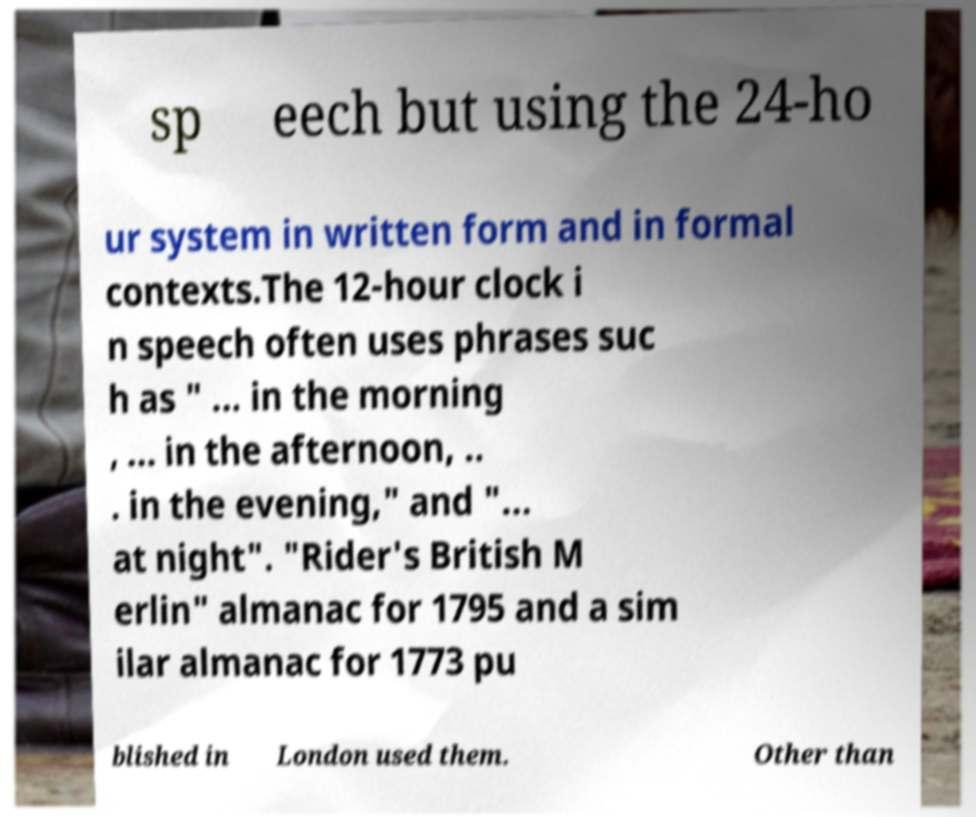Can you read and provide the text displayed in the image?This photo seems to have some interesting text. Can you extract and type it out for me? sp eech but using the 24-ho ur system in written form and in formal contexts.The 12-hour clock i n speech often uses phrases suc h as " ... in the morning , ... in the afternoon, .. . in the evening," and "... at night". "Rider's British M erlin" almanac for 1795 and a sim ilar almanac for 1773 pu blished in London used them. Other than 